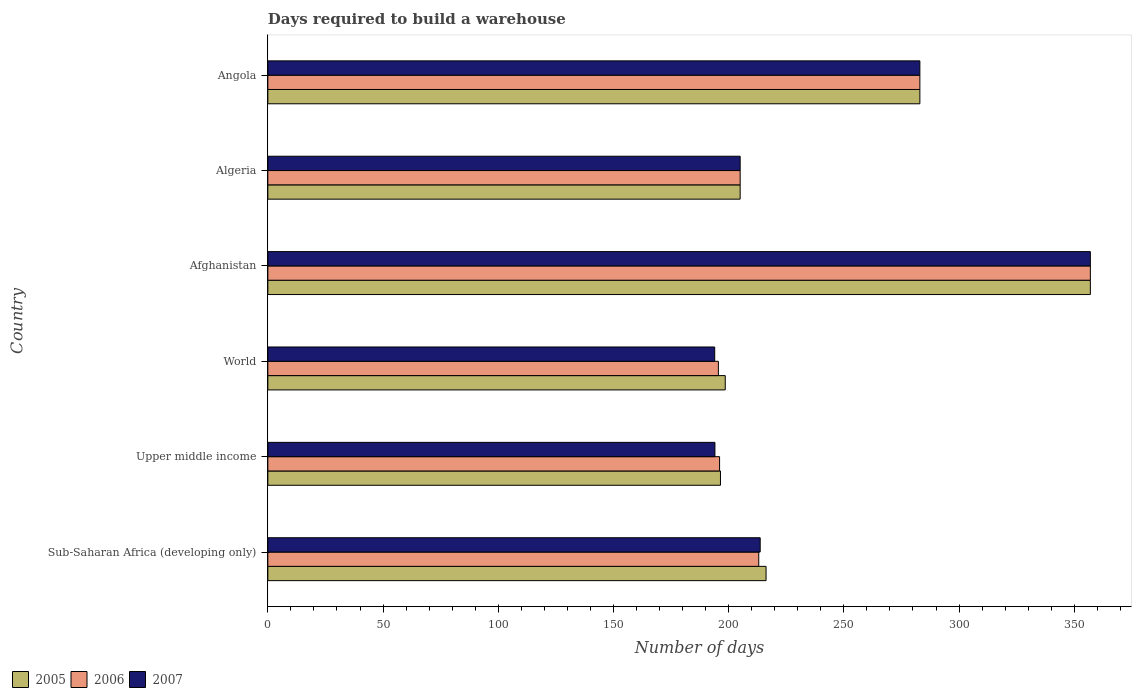Are the number of bars per tick equal to the number of legend labels?
Offer a terse response. Yes. How many bars are there on the 1st tick from the bottom?
Provide a succinct answer. 3. What is the label of the 2nd group of bars from the top?
Your answer should be compact. Algeria. What is the days required to build a warehouse in in 2005 in Angola?
Your response must be concise. 283. Across all countries, what is the maximum days required to build a warehouse in in 2005?
Ensure brevity in your answer.  357. Across all countries, what is the minimum days required to build a warehouse in in 2007?
Your response must be concise. 193.95. In which country was the days required to build a warehouse in in 2006 maximum?
Offer a very short reply. Afghanistan. What is the total days required to build a warehouse in in 2005 in the graph?
Give a very brief answer. 1456.23. What is the difference between the days required to build a warehouse in in 2006 in Angola and that in Upper middle income?
Give a very brief answer. 86.93. What is the difference between the days required to build a warehouse in in 2007 in Algeria and the days required to build a warehouse in in 2006 in World?
Provide a succinct answer. 9.45. What is the average days required to build a warehouse in in 2006 per country?
Offer a very short reply. 241.61. What is the difference between the days required to build a warehouse in in 2006 and days required to build a warehouse in in 2007 in Angola?
Provide a short and direct response. 0. In how many countries, is the days required to build a warehouse in in 2006 greater than 240 days?
Ensure brevity in your answer.  2. What is the ratio of the days required to build a warehouse in in 2005 in Afghanistan to that in Sub-Saharan Africa (developing only)?
Ensure brevity in your answer.  1.65. Is the days required to build a warehouse in in 2007 in Afghanistan less than that in Sub-Saharan Africa (developing only)?
Give a very brief answer. No. What is the difference between the highest and the second highest days required to build a warehouse in in 2005?
Provide a succinct answer. 74. What is the difference between the highest and the lowest days required to build a warehouse in in 2006?
Your response must be concise. 161.45. In how many countries, is the days required to build a warehouse in in 2007 greater than the average days required to build a warehouse in in 2007 taken over all countries?
Offer a terse response. 2. What does the 2nd bar from the top in Algeria represents?
Offer a very short reply. 2006. How many countries are there in the graph?
Offer a terse response. 6. What is the difference between two consecutive major ticks on the X-axis?
Your answer should be compact. 50. Does the graph contain any zero values?
Your answer should be very brief. No. Does the graph contain grids?
Make the answer very short. No. How are the legend labels stacked?
Your answer should be compact. Horizontal. What is the title of the graph?
Give a very brief answer. Days required to build a warehouse. Does "1976" appear as one of the legend labels in the graph?
Your answer should be very brief. No. What is the label or title of the X-axis?
Your answer should be compact. Number of days. What is the label or title of the Y-axis?
Offer a very short reply. Country. What is the Number of days in 2005 in Sub-Saharan Africa (developing only)?
Offer a terse response. 216.24. What is the Number of days of 2006 in Sub-Saharan Africa (developing only)?
Your answer should be very brief. 213.07. What is the Number of days in 2007 in Sub-Saharan Africa (developing only)?
Your answer should be very brief. 213.69. What is the Number of days in 2005 in Upper middle income?
Keep it short and to the point. 196.45. What is the Number of days in 2006 in Upper middle income?
Your answer should be very brief. 196.07. What is the Number of days of 2007 in Upper middle income?
Give a very brief answer. 194.04. What is the Number of days of 2005 in World?
Your answer should be very brief. 198.53. What is the Number of days of 2006 in World?
Ensure brevity in your answer.  195.55. What is the Number of days of 2007 in World?
Ensure brevity in your answer.  193.95. What is the Number of days in 2005 in Afghanistan?
Provide a succinct answer. 357. What is the Number of days in 2006 in Afghanistan?
Make the answer very short. 357. What is the Number of days in 2007 in Afghanistan?
Offer a terse response. 357. What is the Number of days of 2005 in Algeria?
Make the answer very short. 205. What is the Number of days in 2006 in Algeria?
Offer a terse response. 205. What is the Number of days in 2007 in Algeria?
Offer a terse response. 205. What is the Number of days of 2005 in Angola?
Your answer should be compact. 283. What is the Number of days in 2006 in Angola?
Your answer should be compact. 283. What is the Number of days of 2007 in Angola?
Ensure brevity in your answer.  283. Across all countries, what is the maximum Number of days of 2005?
Keep it short and to the point. 357. Across all countries, what is the maximum Number of days in 2006?
Keep it short and to the point. 357. Across all countries, what is the maximum Number of days of 2007?
Keep it short and to the point. 357. Across all countries, what is the minimum Number of days of 2005?
Ensure brevity in your answer.  196.45. Across all countries, what is the minimum Number of days of 2006?
Your answer should be compact. 195.55. Across all countries, what is the minimum Number of days of 2007?
Make the answer very short. 193.95. What is the total Number of days in 2005 in the graph?
Offer a terse response. 1456.23. What is the total Number of days in 2006 in the graph?
Provide a short and direct response. 1449.68. What is the total Number of days in 2007 in the graph?
Your response must be concise. 1446.68. What is the difference between the Number of days in 2005 in Sub-Saharan Africa (developing only) and that in Upper middle income?
Give a very brief answer. 19.79. What is the difference between the Number of days in 2006 in Sub-Saharan Africa (developing only) and that in Upper middle income?
Make the answer very short. 17. What is the difference between the Number of days of 2007 in Sub-Saharan Africa (developing only) and that in Upper middle income?
Offer a very short reply. 19.65. What is the difference between the Number of days in 2005 in Sub-Saharan Africa (developing only) and that in World?
Offer a terse response. 17.72. What is the difference between the Number of days in 2006 in Sub-Saharan Africa (developing only) and that in World?
Your response must be concise. 17.53. What is the difference between the Number of days in 2007 in Sub-Saharan Africa (developing only) and that in World?
Give a very brief answer. 19.74. What is the difference between the Number of days of 2005 in Sub-Saharan Africa (developing only) and that in Afghanistan?
Provide a short and direct response. -140.76. What is the difference between the Number of days of 2006 in Sub-Saharan Africa (developing only) and that in Afghanistan?
Your answer should be very brief. -143.93. What is the difference between the Number of days of 2007 in Sub-Saharan Africa (developing only) and that in Afghanistan?
Provide a short and direct response. -143.31. What is the difference between the Number of days in 2005 in Sub-Saharan Africa (developing only) and that in Algeria?
Your answer should be compact. 11.24. What is the difference between the Number of days of 2006 in Sub-Saharan Africa (developing only) and that in Algeria?
Offer a very short reply. 8.07. What is the difference between the Number of days in 2007 in Sub-Saharan Africa (developing only) and that in Algeria?
Offer a very short reply. 8.69. What is the difference between the Number of days of 2005 in Sub-Saharan Africa (developing only) and that in Angola?
Give a very brief answer. -66.76. What is the difference between the Number of days of 2006 in Sub-Saharan Africa (developing only) and that in Angola?
Your answer should be very brief. -69.93. What is the difference between the Number of days of 2007 in Sub-Saharan Africa (developing only) and that in Angola?
Provide a short and direct response. -69.31. What is the difference between the Number of days in 2005 in Upper middle income and that in World?
Your response must be concise. -2.07. What is the difference between the Number of days of 2006 in Upper middle income and that in World?
Make the answer very short. 0.52. What is the difference between the Number of days of 2007 in Upper middle income and that in World?
Provide a succinct answer. 0.09. What is the difference between the Number of days of 2005 in Upper middle income and that in Afghanistan?
Offer a terse response. -160.55. What is the difference between the Number of days in 2006 in Upper middle income and that in Afghanistan?
Provide a succinct answer. -160.93. What is the difference between the Number of days in 2007 in Upper middle income and that in Afghanistan?
Provide a succinct answer. -162.96. What is the difference between the Number of days in 2005 in Upper middle income and that in Algeria?
Offer a very short reply. -8.55. What is the difference between the Number of days in 2006 in Upper middle income and that in Algeria?
Your response must be concise. -8.93. What is the difference between the Number of days in 2007 in Upper middle income and that in Algeria?
Keep it short and to the point. -10.96. What is the difference between the Number of days of 2005 in Upper middle income and that in Angola?
Give a very brief answer. -86.55. What is the difference between the Number of days of 2006 in Upper middle income and that in Angola?
Offer a very short reply. -86.93. What is the difference between the Number of days of 2007 in Upper middle income and that in Angola?
Your answer should be very brief. -88.96. What is the difference between the Number of days in 2005 in World and that in Afghanistan?
Provide a short and direct response. -158.47. What is the difference between the Number of days of 2006 in World and that in Afghanistan?
Ensure brevity in your answer.  -161.45. What is the difference between the Number of days in 2007 in World and that in Afghanistan?
Provide a succinct answer. -163.05. What is the difference between the Number of days in 2005 in World and that in Algeria?
Your answer should be very brief. -6.47. What is the difference between the Number of days in 2006 in World and that in Algeria?
Your response must be concise. -9.45. What is the difference between the Number of days of 2007 in World and that in Algeria?
Offer a very short reply. -11.05. What is the difference between the Number of days in 2005 in World and that in Angola?
Offer a terse response. -84.47. What is the difference between the Number of days of 2006 in World and that in Angola?
Your answer should be compact. -87.45. What is the difference between the Number of days in 2007 in World and that in Angola?
Your response must be concise. -89.05. What is the difference between the Number of days in 2005 in Afghanistan and that in Algeria?
Your response must be concise. 152. What is the difference between the Number of days of 2006 in Afghanistan and that in Algeria?
Offer a very short reply. 152. What is the difference between the Number of days in 2007 in Afghanistan and that in Algeria?
Offer a terse response. 152. What is the difference between the Number of days of 2005 in Afghanistan and that in Angola?
Keep it short and to the point. 74. What is the difference between the Number of days in 2006 in Afghanistan and that in Angola?
Offer a very short reply. 74. What is the difference between the Number of days in 2007 in Afghanistan and that in Angola?
Make the answer very short. 74. What is the difference between the Number of days in 2005 in Algeria and that in Angola?
Ensure brevity in your answer.  -78. What is the difference between the Number of days of 2006 in Algeria and that in Angola?
Ensure brevity in your answer.  -78. What is the difference between the Number of days of 2007 in Algeria and that in Angola?
Make the answer very short. -78. What is the difference between the Number of days in 2005 in Sub-Saharan Africa (developing only) and the Number of days in 2006 in Upper middle income?
Offer a very short reply. 20.18. What is the difference between the Number of days of 2005 in Sub-Saharan Africa (developing only) and the Number of days of 2007 in Upper middle income?
Your answer should be compact. 22.2. What is the difference between the Number of days in 2006 in Sub-Saharan Africa (developing only) and the Number of days in 2007 in Upper middle income?
Give a very brief answer. 19.03. What is the difference between the Number of days in 2005 in Sub-Saharan Africa (developing only) and the Number of days in 2006 in World?
Offer a very short reply. 20.7. What is the difference between the Number of days in 2005 in Sub-Saharan Africa (developing only) and the Number of days in 2007 in World?
Offer a terse response. 22.29. What is the difference between the Number of days in 2006 in Sub-Saharan Africa (developing only) and the Number of days in 2007 in World?
Ensure brevity in your answer.  19.12. What is the difference between the Number of days of 2005 in Sub-Saharan Africa (developing only) and the Number of days of 2006 in Afghanistan?
Give a very brief answer. -140.76. What is the difference between the Number of days of 2005 in Sub-Saharan Africa (developing only) and the Number of days of 2007 in Afghanistan?
Give a very brief answer. -140.76. What is the difference between the Number of days of 2006 in Sub-Saharan Africa (developing only) and the Number of days of 2007 in Afghanistan?
Offer a very short reply. -143.93. What is the difference between the Number of days in 2005 in Sub-Saharan Africa (developing only) and the Number of days in 2006 in Algeria?
Keep it short and to the point. 11.24. What is the difference between the Number of days of 2005 in Sub-Saharan Africa (developing only) and the Number of days of 2007 in Algeria?
Keep it short and to the point. 11.24. What is the difference between the Number of days in 2006 in Sub-Saharan Africa (developing only) and the Number of days in 2007 in Algeria?
Offer a terse response. 8.07. What is the difference between the Number of days in 2005 in Sub-Saharan Africa (developing only) and the Number of days in 2006 in Angola?
Provide a short and direct response. -66.76. What is the difference between the Number of days of 2005 in Sub-Saharan Africa (developing only) and the Number of days of 2007 in Angola?
Offer a very short reply. -66.76. What is the difference between the Number of days of 2006 in Sub-Saharan Africa (developing only) and the Number of days of 2007 in Angola?
Your answer should be very brief. -69.93. What is the difference between the Number of days in 2005 in Upper middle income and the Number of days in 2006 in World?
Your answer should be compact. 0.91. What is the difference between the Number of days of 2005 in Upper middle income and the Number of days of 2007 in World?
Offer a very short reply. 2.5. What is the difference between the Number of days in 2006 in Upper middle income and the Number of days in 2007 in World?
Keep it short and to the point. 2.12. What is the difference between the Number of days in 2005 in Upper middle income and the Number of days in 2006 in Afghanistan?
Keep it short and to the point. -160.55. What is the difference between the Number of days in 2005 in Upper middle income and the Number of days in 2007 in Afghanistan?
Your answer should be compact. -160.55. What is the difference between the Number of days of 2006 in Upper middle income and the Number of days of 2007 in Afghanistan?
Give a very brief answer. -160.93. What is the difference between the Number of days in 2005 in Upper middle income and the Number of days in 2006 in Algeria?
Provide a succinct answer. -8.55. What is the difference between the Number of days in 2005 in Upper middle income and the Number of days in 2007 in Algeria?
Provide a short and direct response. -8.55. What is the difference between the Number of days in 2006 in Upper middle income and the Number of days in 2007 in Algeria?
Your answer should be very brief. -8.93. What is the difference between the Number of days of 2005 in Upper middle income and the Number of days of 2006 in Angola?
Give a very brief answer. -86.55. What is the difference between the Number of days in 2005 in Upper middle income and the Number of days in 2007 in Angola?
Provide a succinct answer. -86.55. What is the difference between the Number of days in 2006 in Upper middle income and the Number of days in 2007 in Angola?
Your answer should be compact. -86.93. What is the difference between the Number of days of 2005 in World and the Number of days of 2006 in Afghanistan?
Offer a terse response. -158.47. What is the difference between the Number of days in 2005 in World and the Number of days in 2007 in Afghanistan?
Your answer should be very brief. -158.47. What is the difference between the Number of days of 2006 in World and the Number of days of 2007 in Afghanistan?
Keep it short and to the point. -161.45. What is the difference between the Number of days of 2005 in World and the Number of days of 2006 in Algeria?
Your answer should be very brief. -6.47. What is the difference between the Number of days of 2005 in World and the Number of days of 2007 in Algeria?
Provide a succinct answer. -6.47. What is the difference between the Number of days of 2006 in World and the Number of days of 2007 in Algeria?
Ensure brevity in your answer.  -9.45. What is the difference between the Number of days of 2005 in World and the Number of days of 2006 in Angola?
Your response must be concise. -84.47. What is the difference between the Number of days of 2005 in World and the Number of days of 2007 in Angola?
Provide a short and direct response. -84.47. What is the difference between the Number of days in 2006 in World and the Number of days in 2007 in Angola?
Give a very brief answer. -87.45. What is the difference between the Number of days of 2005 in Afghanistan and the Number of days of 2006 in Algeria?
Give a very brief answer. 152. What is the difference between the Number of days in 2005 in Afghanistan and the Number of days in 2007 in Algeria?
Give a very brief answer. 152. What is the difference between the Number of days in 2006 in Afghanistan and the Number of days in 2007 in Algeria?
Offer a terse response. 152. What is the difference between the Number of days of 2005 in Afghanistan and the Number of days of 2006 in Angola?
Offer a very short reply. 74. What is the difference between the Number of days of 2006 in Afghanistan and the Number of days of 2007 in Angola?
Offer a very short reply. 74. What is the difference between the Number of days of 2005 in Algeria and the Number of days of 2006 in Angola?
Offer a terse response. -78. What is the difference between the Number of days in 2005 in Algeria and the Number of days in 2007 in Angola?
Provide a short and direct response. -78. What is the difference between the Number of days of 2006 in Algeria and the Number of days of 2007 in Angola?
Give a very brief answer. -78. What is the average Number of days in 2005 per country?
Offer a terse response. 242.7. What is the average Number of days of 2006 per country?
Offer a terse response. 241.61. What is the average Number of days of 2007 per country?
Your response must be concise. 241.11. What is the difference between the Number of days in 2005 and Number of days in 2006 in Sub-Saharan Africa (developing only)?
Ensure brevity in your answer.  3.17. What is the difference between the Number of days in 2005 and Number of days in 2007 in Sub-Saharan Africa (developing only)?
Your answer should be very brief. 2.55. What is the difference between the Number of days of 2006 and Number of days of 2007 in Sub-Saharan Africa (developing only)?
Your answer should be compact. -0.62. What is the difference between the Number of days in 2005 and Number of days in 2006 in Upper middle income?
Offer a terse response. 0.39. What is the difference between the Number of days in 2005 and Number of days in 2007 in Upper middle income?
Provide a succinct answer. 2.41. What is the difference between the Number of days of 2006 and Number of days of 2007 in Upper middle income?
Make the answer very short. 2.02. What is the difference between the Number of days of 2005 and Number of days of 2006 in World?
Offer a very short reply. 2.98. What is the difference between the Number of days of 2005 and Number of days of 2007 in World?
Give a very brief answer. 4.58. What is the difference between the Number of days in 2006 and Number of days in 2007 in World?
Provide a succinct answer. 1.6. What is the difference between the Number of days in 2006 and Number of days in 2007 in Afghanistan?
Your response must be concise. 0. What is the difference between the Number of days in 2005 and Number of days in 2006 in Algeria?
Your answer should be compact. 0. What is the difference between the Number of days in 2005 and Number of days in 2007 in Algeria?
Offer a terse response. 0. What is the difference between the Number of days of 2006 and Number of days of 2007 in Algeria?
Offer a very short reply. 0. What is the difference between the Number of days of 2006 and Number of days of 2007 in Angola?
Offer a terse response. 0. What is the ratio of the Number of days of 2005 in Sub-Saharan Africa (developing only) to that in Upper middle income?
Make the answer very short. 1.1. What is the ratio of the Number of days of 2006 in Sub-Saharan Africa (developing only) to that in Upper middle income?
Make the answer very short. 1.09. What is the ratio of the Number of days in 2007 in Sub-Saharan Africa (developing only) to that in Upper middle income?
Ensure brevity in your answer.  1.1. What is the ratio of the Number of days of 2005 in Sub-Saharan Africa (developing only) to that in World?
Offer a very short reply. 1.09. What is the ratio of the Number of days of 2006 in Sub-Saharan Africa (developing only) to that in World?
Your response must be concise. 1.09. What is the ratio of the Number of days in 2007 in Sub-Saharan Africa (developing only) to that in World?
Your answer should be very brief. 1.1. What is the ratio of the Number of days of 2005 in Sub-Saharan Africa (developing only) to that in Afghanistan?
Your answer should be very brief. 0.61. What is the ratio of the Number of days in 2006 in Sub-Saharan Africa (developing only) to that in Afghanistan?
Your answer should be very brief. 0.6. What is the ratio of the Number of days of 2007 in Sub-Saharan Africa (developing only) to that in Afghanistan?
Make the answer very short. 0.6. What is the ratio of the Number of days of 2005 in Sub-Saharan Africa (developing only) to that in Algeria?
Give a very brief answer. 1.05. What is the ratio of the Number of days in 2006 in Sub-Saharan Africa (developing only) to that in Algeria?
Your answer should be very brief. 1.04. What is the ratio of the Number of days of 2007 in Sub-Saharan Africa (developing only) to that in Algeria?
Make the answer very short. 1.04. What is the ratio of the Number of days of 2005 in Sub-Saharan Africa (developing only) to that in Angola?
Keep it short and to the point. 0.76. What is the ratio of the Number of days in 2006 in Sub-Saharan Africa (developing only) to that in Angola?
Your answer should be compact. 0.75. What is the ratio of the Number of days of 2007 in Sub-Saharan Africa (developing only) to that in Angola?
Your answer should be very brief. 0.76. What is the ratio of the Number of days in 2006 in Upper middle income to that in World?
Make the answer very short. 1. What is the ratio of the Number of days in 2007 in Upper middle income to that in World?
Ensure brevity in your answer.  1. What is the ratio of the Number of days in 2005 in Upper middle income to that in Afghanistan?
Ensure brevity in your answer.  0.55. What is the ratio of the Number of days of 2006 in Upper middle income to that in Afghanistan?
Offer a very short reply. 0.55. What is the ratio of the Number of days in 2007 in Upper middle income to that in Afghanistan?
Offer a very short reply. 0.54. What is the ratio of the Number of days in 2005 in Upper middle income to that in Algeria?
Offer a terse response. 0.96. What is the ratio of the Number of days of 2006 in Upper middle income to that in Algeria?
Ensure brevity in your answer.  0.96. What is the ratio of the Number of days of 2007 in Upper middle income to that in Algeria?
Your response must be concise. 0.95. What is the ratio of the Number of days of 2005 in Upper middle income to that in Angola?
Make the answer very short. 0.69. What is the ratio of the Number of days in 2006 in Upper middle income to that in Angola?
Your answer should be very brief. 0.69. What is the ratio of the Number of days of 2007 in Upper middle income to that in Angola?
Make the answer very short. 0.69. What is the ratio of the Number of days in 2005 in World to that in Afghanistan?
Give a very brief answer. 0.56. What is the ratio of the Number of days in 2006 in World to that in Afghanistan?
Your answer should be compact. 0.55. What is the ratio of the Number of days in 2007 in World to that in Afghanistan?
Provide a succinct answer. 0.54. What is the ratio of the Number of days in 2005 in World to that in Algeria?
Provide a short and direct response. 0.97. What is the ratio of the Number of days of 2006 in World to that in Algeria?
Make the answer very short. 0.95. What is the ratio of the Number of days in 2007 in World to that in Algeria?
Provide a short and direct response. 0.95. What is the ratio of the Number of days of 2005 in World to that in Angola?
Your answer should be very brief. 0.7. What is the ratio of the Number of days of 2006 in World to that in Angola?
Your response must be concise. 0.69. What is the ratio of the Number of days of 2007 in World to that in Angola?
Make the answer very short. 0.69. What is the ratio of the Number of days in 2005 in Afghanistan to that in Algeria?
Ensure brevity in your answer.  1.74. What is the ratio of the Number of days of 2006 in Afghanistan to that in Algeria?
Make the answer very short. 1.74. What is the ratio of the Number of days of 2007 in Afghanistan to that in Algeria?
Ensure brevity in your answer.  1.74. What is the ratio of the Number of days of 2005 in Afghanistan to that in Angola?
Your answer should be very brief. 1.26. What is the ratio of the Number of days of 2006 in Afghanistan to that in Angola?
Your answer should be compact. 1.26. What is the ratio of the Number of days of 2007 in Afghanistan to that in Angola?
Give a very brief answer. 1.26. What is the ratio of the Number of days of 2005 in Algeria to that in Angola?
Provide a succinct answer. 0.72. What is the ratio of the Number of days of 2006 in Algeria to that in Angola?
Provide a succinct answer. 0.72. What is the ratio of the Number of days of 2007 in Algeria to that in Angola?
Your response must be concise. 0.72. What is the difference between the highest and the second highest Number of days in 2006?
Your answer should be compact. 74. What is the difference between the highest and the lowest Number of days in 2005?
Give a very brief answer. 160.55. What is the difference between the highest and the lowest Number of days in 2006?
Your answer should be compact. 161.45. What is the difference between the highest and the lowest Number of days in 2007?
Provide a succinct answer. 163.05. 